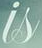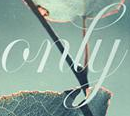What text appears in these images from left to right, separated by a semicolon? is; only 